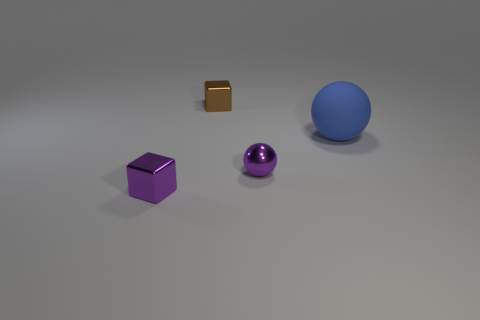Add 1 purple metallic objects. How many objects exist? 5 Subtract 0 gray balls. How many objects are left? 4 Subtract 1 spheres. How many spheres are left? 1 Subtract all gray blocks. Subtract all green cylinders. How many blocks are left? 2 Subtract all large matte objects. Subtract all tiny purple shiny cubes. How many objects are left? 2 Add 3 purple metallic balls. How many purple metallic balls are left? 4 Add 2 small brown metallic objects. How many small brown metallic objects exist? 3 Subtract all purple blocks. How many blocks are left? 1 